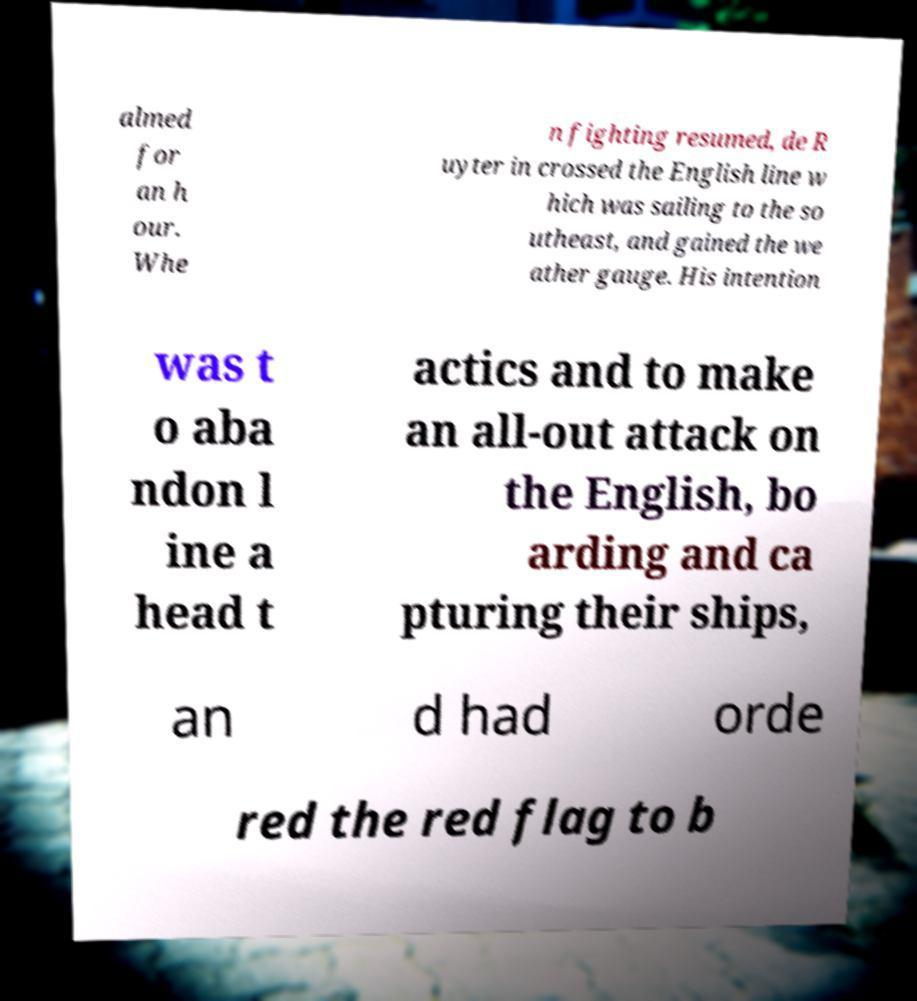Can you read and provide the text displayed in the image?This photo seems to have some interesting text. Can you extract and type it out for me? almed for an h our. Whe n fighting resumed, de R uyter in crossed the English line w hich was sailing to the so utheast, and gained the we ather gauge. His intention was t o aba ndon l ine a head t actics and to make an all-out attack on the English, bo arding and ca pturing their ships, an d had orde red the red flag to b 